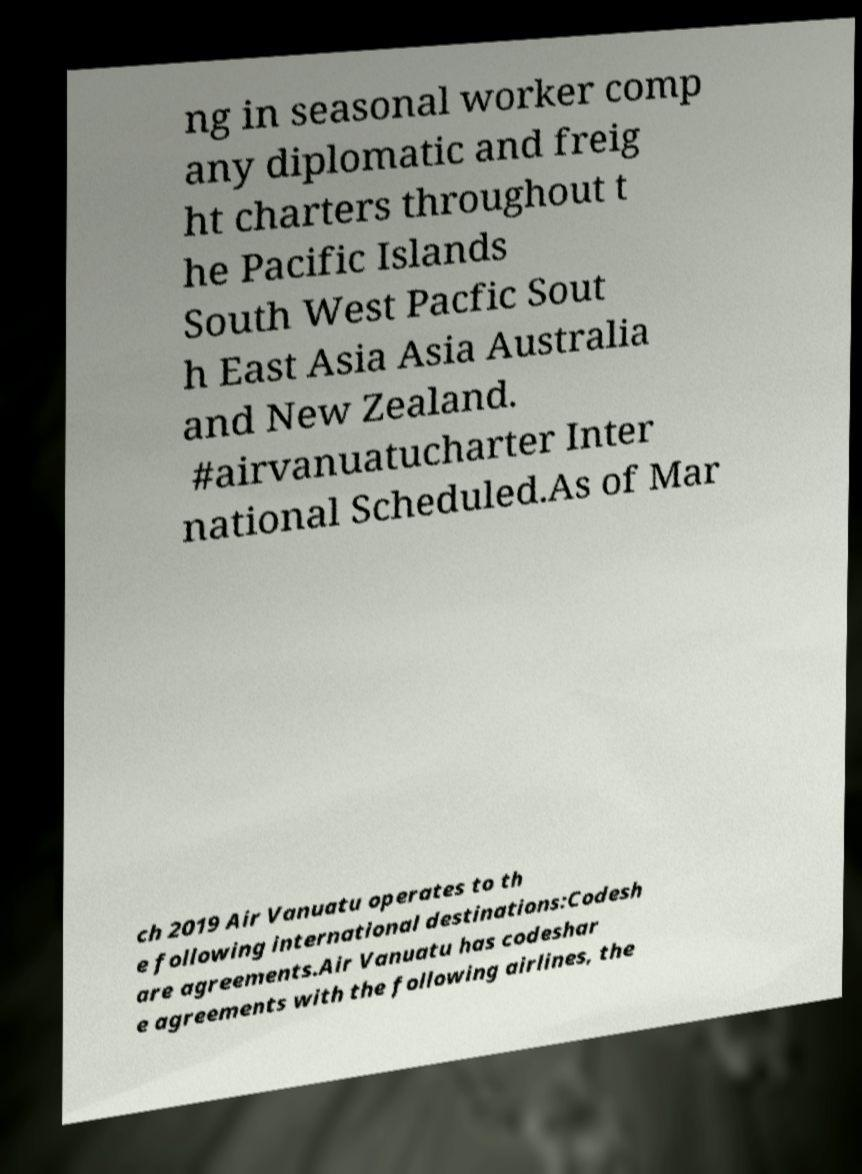There's text embedded in this image that I need extracted. Can you transcribe it verbatim? ng in seasonal worker comp any diplomatic and freig ht charters throughout t he Pacific Islands South West Pacfic Sout h East Asia Asia Australia and New Zealand. #airvanuatucharter Inter national Scheduled.As of Mar ch 2019 Air Vanuatu operates to th e following international destinations:Codesh are agreements.Air Vanuatu has codeshar e agreements with the following airlines, the 